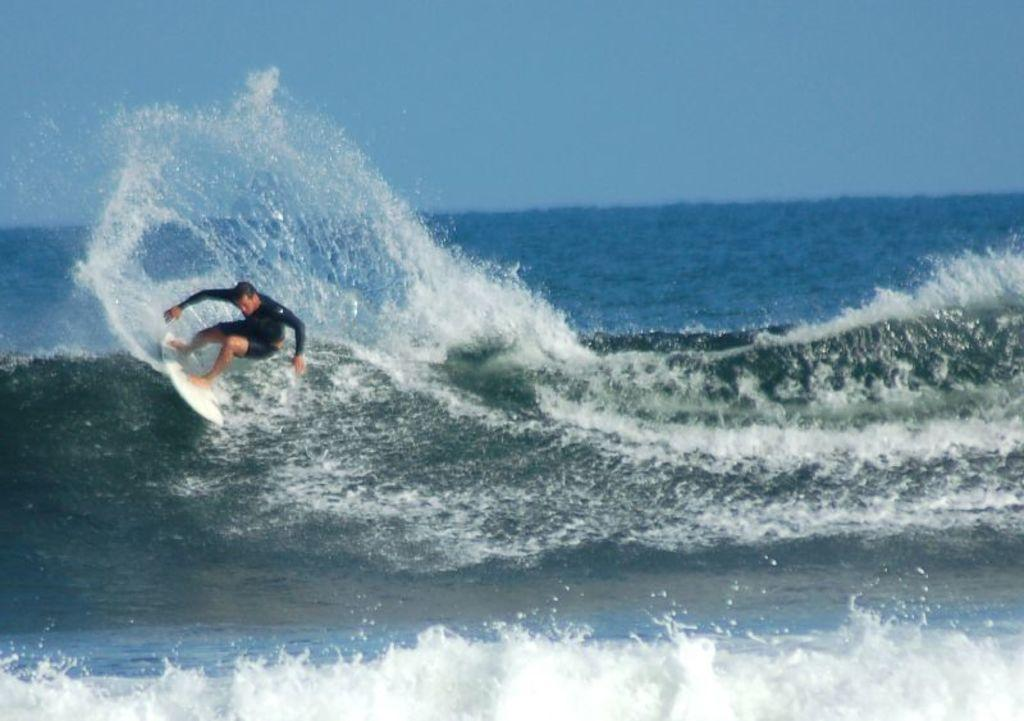What is at the bottom of the image? There is water at the bottom of the image. What can be seen in the foreground of the image? There is a person and waves in the foreground. Is there any water visible in the background of the image? Yes, there is water visible in the background. What is visible at the top of the image? The sky is visible at the top of the image. What type of string is being used by the person in the image to make a discovery? There is no string or discovery present in the image; it features a person in the foreground with waves and water in the background. 